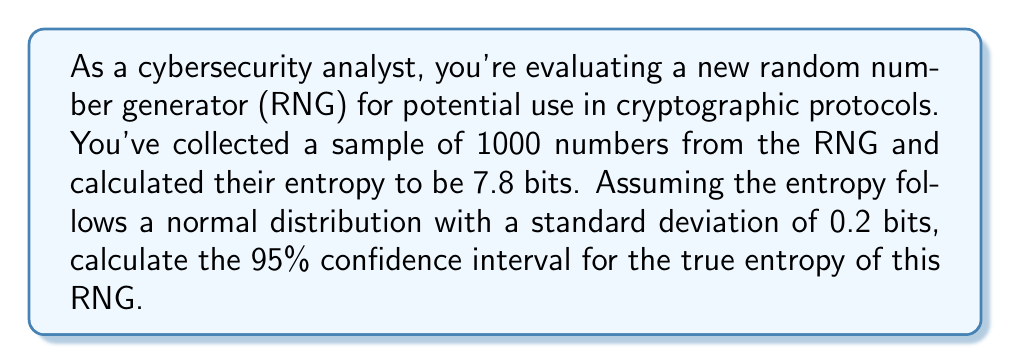Solve this math problem. Let's approach this step-by-step:

1) We're dealing with a confidence interval for a population mean (the true entropy) based on a sample.

2) The formula for a confidence interval is:

   $$\bar{x} \pm z_{\alpha/2} \cdot \frac{\sigma}{\sqrt{n}}$$

   Where:
   $\bar{x}$ is the sample mean
   $z_{\alpha/2}$ is the critical value for the desired confidence level
   $\sigma$ is the population standard deviation
   $n$ is the sample size

3) We're given:
   $\bar{x} = 7.8$ bits (sample entropy)
   $\sigma = 0.2$ bits
   $n = 1000$
   Confidence level = 95%

4) For a 95% confidence interval, $\alpha = 0.05$, and $z_{\alpha/2} = 1.96$

5) Plugging these values into our formula:

   $$7.8 \pm 1.96 \cdot \frac{0.2}{\sqrt{1000}}$$

6) Simplify:
   $$7.8 \pm 1.96 \cdot \frac{0.2}{31.6228}$$
   $$7.8 \pm 1.96 \cdot 0.006325$$
   $$7.8 \pm 0.012397$$

7) Therefore, the confidence interval is:
   $$(7.8 - 0.012397, 7.8 + 0.012397)$$
   $$(7.787603, 7.812397)$$

8) Rounding to three decimal places:
   $$(7.788, 7.812)$$
Answer: (7.788, 7.812) bits 